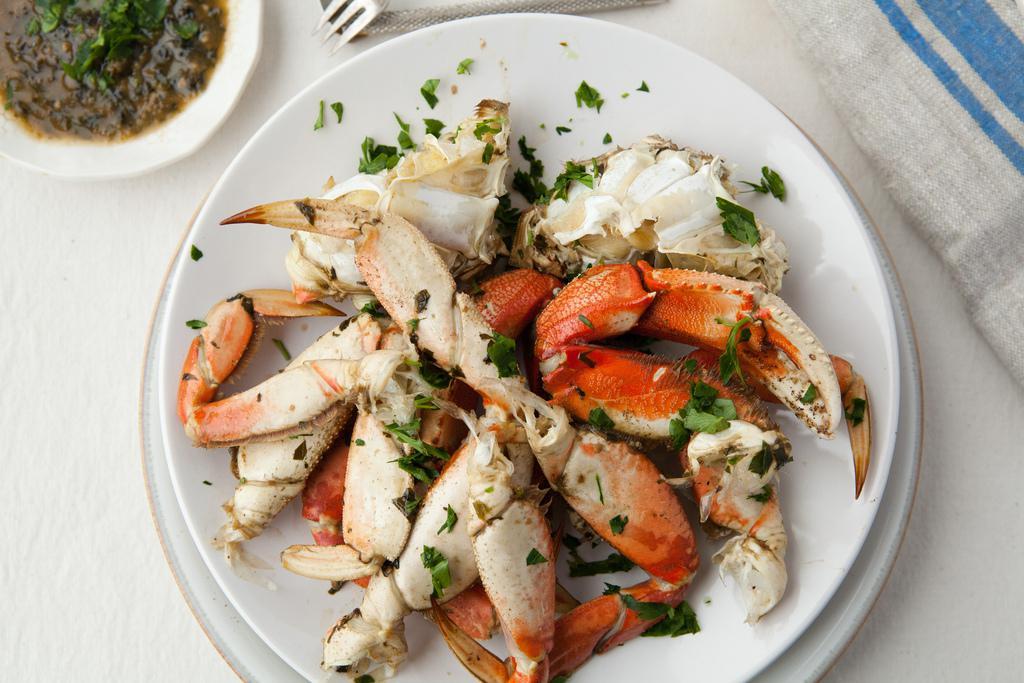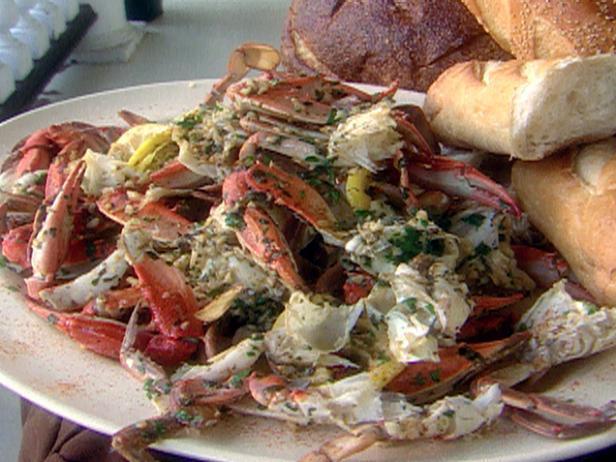The first image is the image on the left, the second image is the image on the right. Assess this claim about the two images: "There are at least two lemons and two lime to season crab legs.". Correct or not? Answer yes or no. No. The first image is the image on the left, the second image is the image on the right. For the images displayed, is the sentence "There is sauce next to the crab meat." factually correct? Answer yes or no. Yes. 